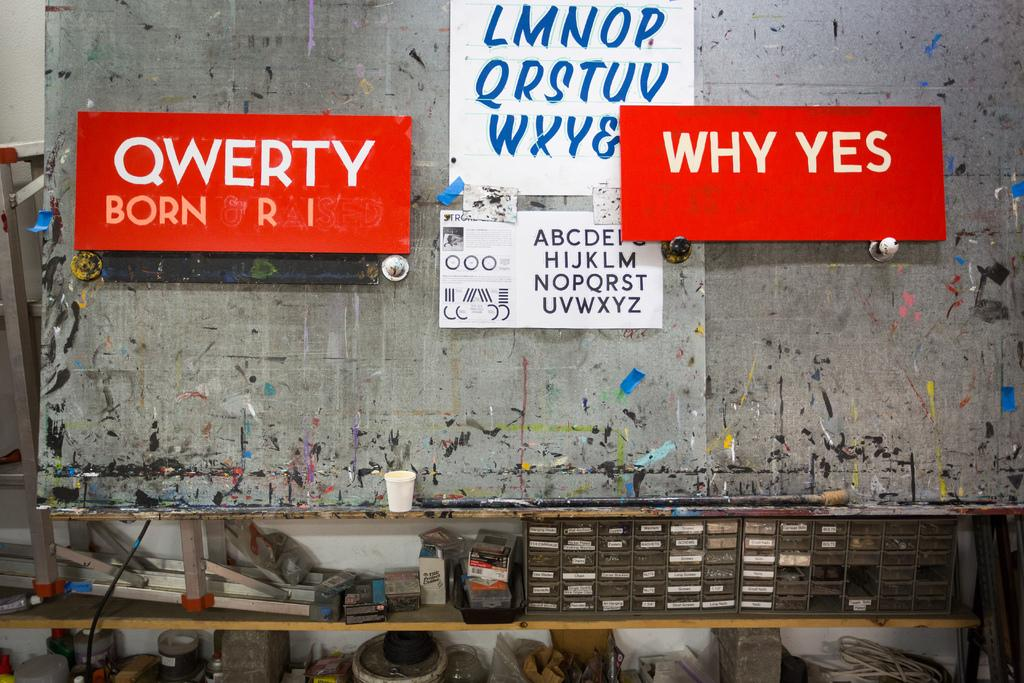<image>
Offer a succinct explanation of the picture presented. Grey wall with red signs that say "QWERTY" and "WHY YES". 